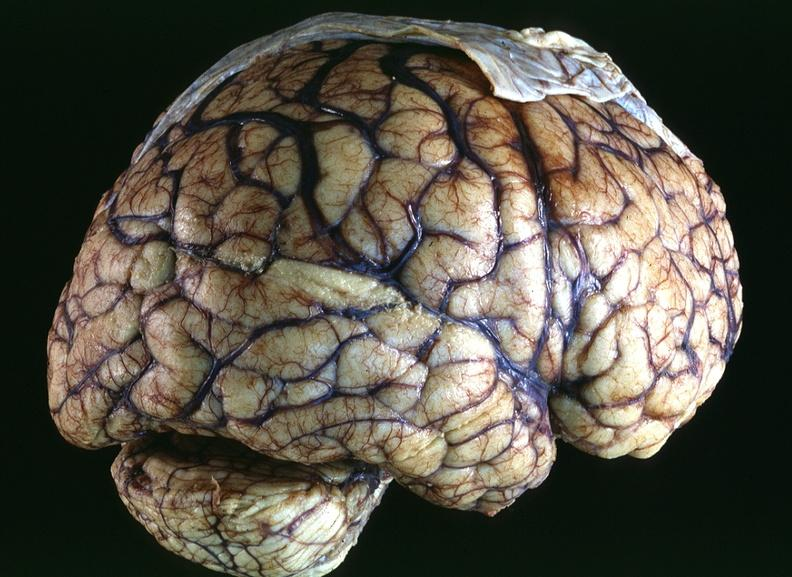does metastatic pancreas carcinoma show toxoplasmosis, brain?
Answer the question using a single word or phrase. No 